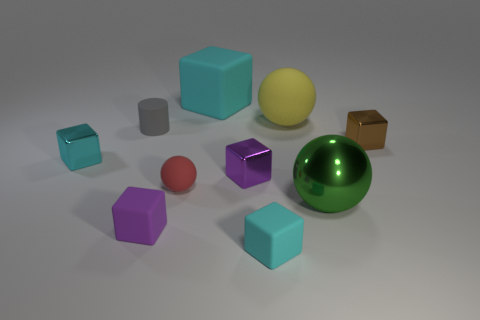Subtract all large shiny balls. How many balls are left? 2 Subtract all green spheres. How many spheres are left? 2 Subtract 1 cubes. How many cubes are left? 5 Subtract all balls. How many objects are left? 7 Subtract all brown balls. How many green blocks are left? 0 Subtract all big gray metal spheres. Subtract all purple objects. How many objects are left? 8 Add 8 big yellow rubber balls. How many big yellow rubber balls are left? 9 Add 4 gray rubber cylinders. How many gray rubber cylinders exist? 5 Subtract 0 blue cubes. How many objects are left? 10 Subtract all blue cubes. Subtract all green cylinders. How many cubes are left? 6 